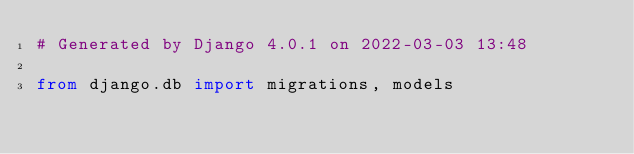Convert code to text. <code><loc_0><loc_0><loc_500><loc_500><_Python_># Generated by Django 4.0.1 on 2022-03-03 13:48

from django.db import migrations, models

</code> 